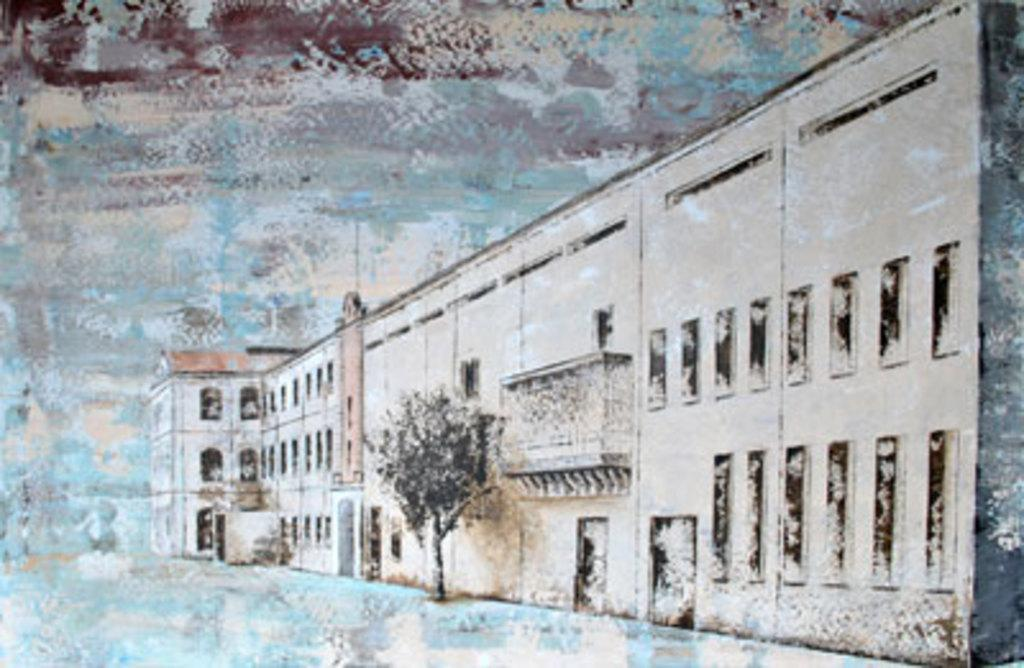What type of natural element is present in the image? There is a tree in the image. What type of man-made structure is present in the image? There is a building in the image. What type of bells can be heard ringing in the image? There are no bells present in the image, and therefore no sound can be heard. 